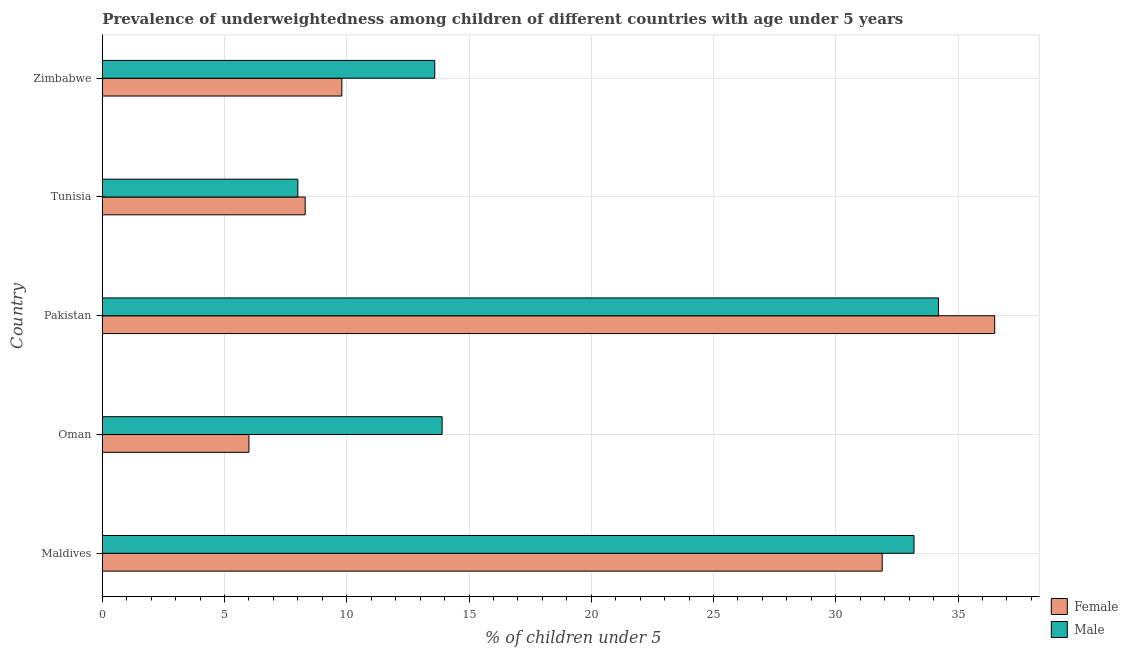In how many cases, is the number of bars for a given country not equal to the number of legend labels?
Ensure brevity in your answer.  0. What is the percentage of underweighted male children in Pakistan?
Your response must be concise. 34.2. Across all countries, what is the maximum percentage of underweighted male children?
Keep it short and to the point. 34.2. In which country was the percentage of underweighted male children maximum?
Your response must be concise. Pakistan. In which country was the percentage of underweighted male children minimum?
Give a very brief answer. Tunisia. What is the total percentage of underweighted male children in the graph?
Your response must be concise. 102.9. What is the difference between the percentage of underweighted male children in Maldives and that in Tunisia?
Your answer should be compact. 25.2. What is the difference between the percentage of underweighted female children in Pakistan and the percentage of underweighted male children in Zimbabwe?
Give a very brief answer. 22.9. What is the average percentage of underweighted male children per country?
Make the answer very short. 20.58. What is the difference between the percentage of underweighted male children and percentage of underweighted female children in Maldives?
Offer a very short reply. 1.3. What is the ratio of the percentage of underweighted male children in Maldives to that in Tunisia?
Provide a succinct answer. 4.15. Is the difference between the percentage of underweighted male children in Pakistan and Zimbabwe greater than the difference between the percentage of underweighted female children in Pakistan and Zimbabwe?
Your answer should be very brief. No. What is the difference between the highest and the lowest percentage of underweighted male children?
Offer a terse response. 26.2. In how many countries, is the percentage of underweighted female children greater than the average percentage of underweighted female children taken over all countries?
Make the answer very short. 2. Is the sum of the percentage of underweighted male children in Maldives and Pakistan greater than the maximum percentage of underweighted female children across all countries?
Make the answer very short. Yes. How many bars are there?
Provide a succinct answer. 10. What is the difference between two consecutive major ticks on the X-axis?
Provide a succinct answer. 5. Does the graph contain any zero values?
Offer a very short reply. No. Where does the legend appear in the graph?
Provide a succinct answer. Bottom right. How many legend labels are there?
Keep it short and to the point. 2. What is the title of the graph?
Make the answer very short. Prevalence of underweightedness among children of different countries with age under 5 years. What is the label or title of the X-axis?
Offer a terse response.  % of children under 5. What is the  % of children under 5 of Female in Maldives?
Your answer should be very brief. 31.9. What is the  % of children under 5 of Male in Maldives?
Offer a terse response. 33.2. What is the  % of children under 5 of Female in Oman?
Your answer should be compact. 6. What is the  % of children under 5 in Male in Oman?
Make the answer very short. 13.9. What is the  % of children under 5 of Female in Pakistan?
Provide a short and direct response. 36.5. What is the  % of children under 5 of Male in Pakistan?
Your answer should be very brief. 34.2. What is the  % of children under 5 in Female in Tunisia?
Provide a short and direct response. 8.3. What is the  % of children under 5 in Male in Tunisia?
Ensure brevity in your answer.  8. What is the  % of children under 5 of Female in Zimbabwe?
Offer a very short reply. 9.8. What is the  % of children under 5 of Male in Zimbabwe?
Your answer should be compact. 13.6. Across all countries, what is the maximum  % of children under 5 of Female?
Your answer should be very brief. 36.5. Across all countries, what is the maximum  % of children under 5 of Male?
Your answer should be very brief. 34.2. Across all countries, what is the minimum  % of children under 5 in Female?
Offer a terse response. 6. Across all countries, what is the minimum  % of children under 5 in Male?
Offer a very short reply. 8. What is the total  % of children under 5 in Female in the graph?
Offer a terse response. 92.5. What is the total  % of children under 5 of Male in the graph?
Your answer should be compact. 102.9. What is the difference between the  % of children under 5 of Female in Maldives and that in Oman?
Offer a very short reply. 25.9. What is the difference between the  % of children under 5 of Male in Maldives and that in Oman?
Your answer should be very brief. 19.3. What is the difference between the  % of children under 5 in Female in Maldives and that in Tunisia?
Give a very brief answer. 23.6. What is the difference between the  % of children under 5 in Male in Maldives and that in Tunisia?
Give a very brief answer. 25.2. What is the difference between the  % of children under 5 of Female in Maldives and that in Zimbabwe?
Keep it short and to the point. 22.1. What is the difference between the  % of children under 5 in Male in Maldives and that in Zimbabwe?
Your answer should be compact. 19.6. What is the difference between the  % of children under 5 in Female in Oman and that in Pakistan?
Ensure brevity in your answer.  -30.5. What is the difference between the  % of children under 5 in Male in Oman and that in Pakistan?
Offer a terse response. -20.3. What is the difference between the  % of children under 5 of Female in Oman and that in Tunisia?
Your answer should be very brief. -2.3. What is the difference between the  % of children under 5 in Male in Oman and that in Tunisia?
Provide a succinct answer. 5.9. What is the difference between the  % of children under 5 of Female in Pakistan and that in Tunisia?
Give a very brief answer. 28.2. What is the difference between the  % of children under 5 in Male in Pakistan and that in Tunisia?
Your response must be concise. 26.2. What is the difference between the  % of children under 5 of Female in Pakistan and that in Zimbabwe?
Offer a terse response. 26.7. What is the difference between the  % of children under 5 in Male in Pakistan and that in Zimbabwe?
Your response must be concise. 20.6. What is the difference between the  % of children under 5 in Female in Maldives and the  % of children under 5 in Male in Oman?
Provide a short and direct response. 18. What is the difference between the  % of children under 5 in Female in Maldives and the  % of children under 5 in Male in Pakistan?
Ensure brevity in your answer.  -2.3. What is the difference between the  % of children under 5 in Female in Maldives and the  % of children under 5 in Male in Tunisia?
Give a very brief answer. 23.9. What is the difference between the  % of children under 5 of Female in Oman and the  % of children under 5 of Male in Pakistan?
Your answer should be very brief. -28.2. What is the difference between the  % of children under 5 of Female in Pakistan and the  % of children under 5 of Male in Zimbabwe?
Keep it short and to the point. 22.9. What is the difference between the  % of children under 5 in Female in Tunisia and the  % of children under 5 in Male in Zimbabwe?
Provide a short and direct response. -5.3. What is the average  % of children under 5 in Male per country?
Your answer should be compact. 20.58. What is the difference between the  % of children under 5 in Female and  % of children under 5 in Male in Oman?
Offer a terse response. -7.9. What is the difference between the  % of children under 5 of Female and  % of children under 5 of Male in Pakistan?
Offer a terse response. 2.3. What is the difference between the  % of children under 5 of Female and  % of children under 5 of Male in Zimbabwe?
Your answer should be very brief. -3.8. What is the ratio of the  % of children under 5 in Female in Maldives to that in Oman?
Provide a succinct answer. 5.32. What is the ratio of the  % of children under 5 of Male in Maldives to that in Oman?
Your answer should be very brief. 2.39. What is the ratio of the  % of children under 5 in Female in Maldives to that in Pakistan?
Keep it short and to the point. 0.87. What is the ratio of the  % of children under 5 of Male in Maldives to that in Pakistan?
Provide a short and direct response. 0.97. What is the ratio of the  % of children under 5 in Female in Maldives to that in Tunisia?
Your response must be concise. 3.84. What is the ratio of the  % of children under 5 in Male in Maldives to that in Tunisia?
Ensure brevity in your answer.  4.15. What is the ratio of the  % of children under 5 of Female in Maldives to that in Zimbabwe?
Provide a succinct answer. 3.26. What is the ratio of the  % of children under 5 in Male in Maldives to that in Zimbabwe?
Offer a terse response. 2.44. What is the ratio of the  % of children under 5 of Female in Oman to that in Pakistan?
Your response must be concise. 0.16. What is the ratio of the  % of children under 5 in Male in Oman to that in Pakistan?
Your answer should be very brief. 0.41. What is the ratio of the  % of children under 5 of Female in Oman to that in Tunisia?
Give a very brief answer. 0.72. What is the ratio of the  % of children under 5 in Male in Oman to that in Tunisia?
Ensure brevity in your answer.  1.74. What is the ratio of the  % of children under 5 in Female in Oman to that in Zimbabwe?
Keep it short and to the point. 0.61. What is the ratio of the  % of children under 5 in Male in Oman to that in Zimbabwe?
Your answer should be very brief. 1.02. What is the ratio of the  % of children under 5 in Female in Pakistan to that in Tunisia?
Your answer should be very brief. 4.4. What is the ratio of the  % of children under 5 in Male in Pakistan to that in Tunisia?
Your answer should be compact. 4.28. What is the ratio of the  % of children under 5 in Female in Pakistan to that in Zimbabwe?
Offer a terse response. 3.72. What is the ratio of the  % of children under 5 in Male in Pakistan to that in Zimbabwe?
Make the answer very short. 2.51. What is the ratio of the  % of children under 5 in Female in Tunisia to that in Zimbabwe?
Offer a terse response. 0.85. What is the ratio of the  % of children under 5 of Male in Tunisia to that in Zimbabwe?
Your answer should be compact. 0.59. What is the difference between the highest and the second highest  % of children under 5 of Male?
Provide a short and direct response. 1. What is the difference between the highest and the lowest  % of children under 5 of Female?
Your answer should be very brief. 30.5. What is the difference between the highest and the lowest  % of children under 5 of Male?
Provide a short and direct response. 26.2. 